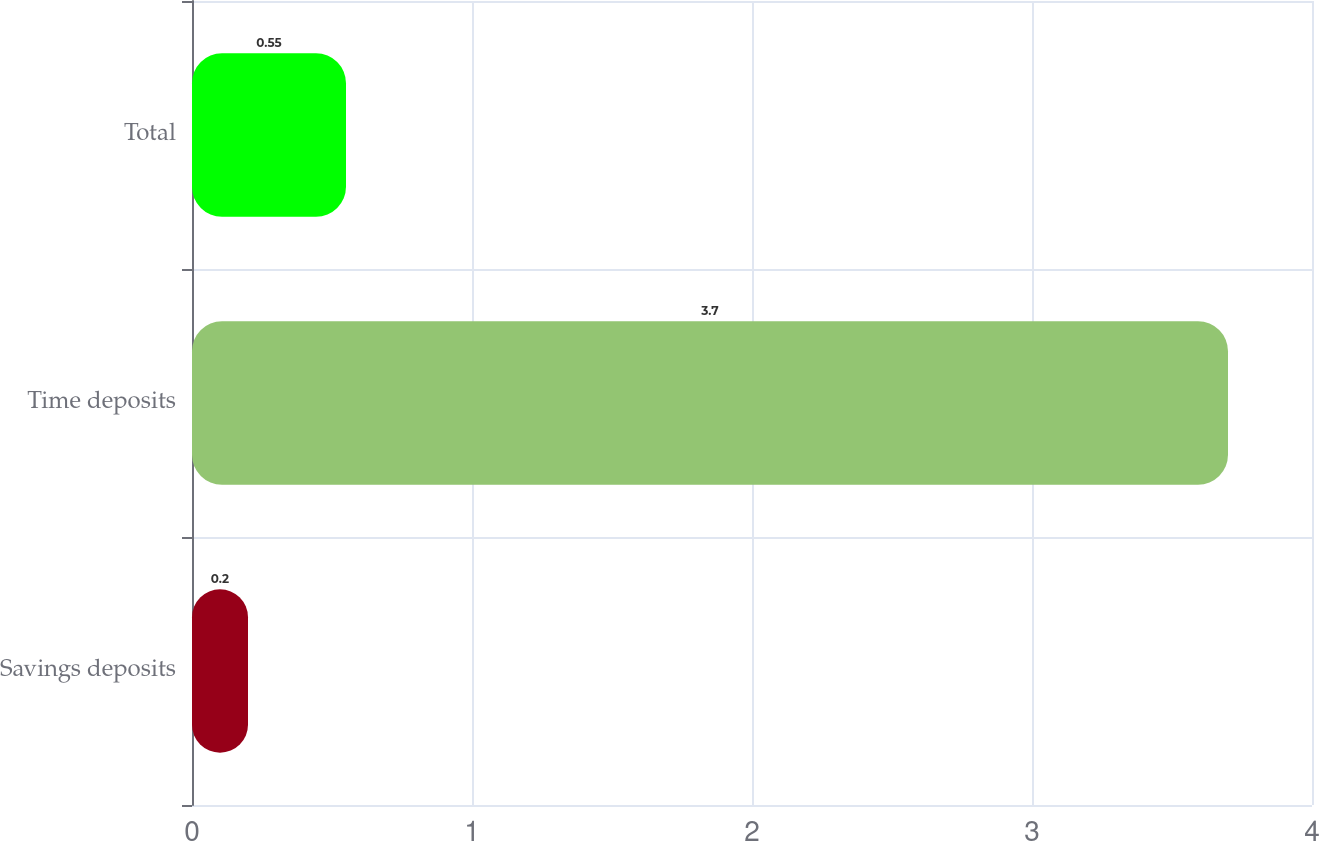Convert chart to OTSL. <chart><loc_0><loc_0><loc_500><loc_500><bar_chart><fcel>Savings deposits<fcel>Time deposits<fcel>Total<nl><fcel>0.2<fcel>3.7<fcel>0.55<nl></chart> 